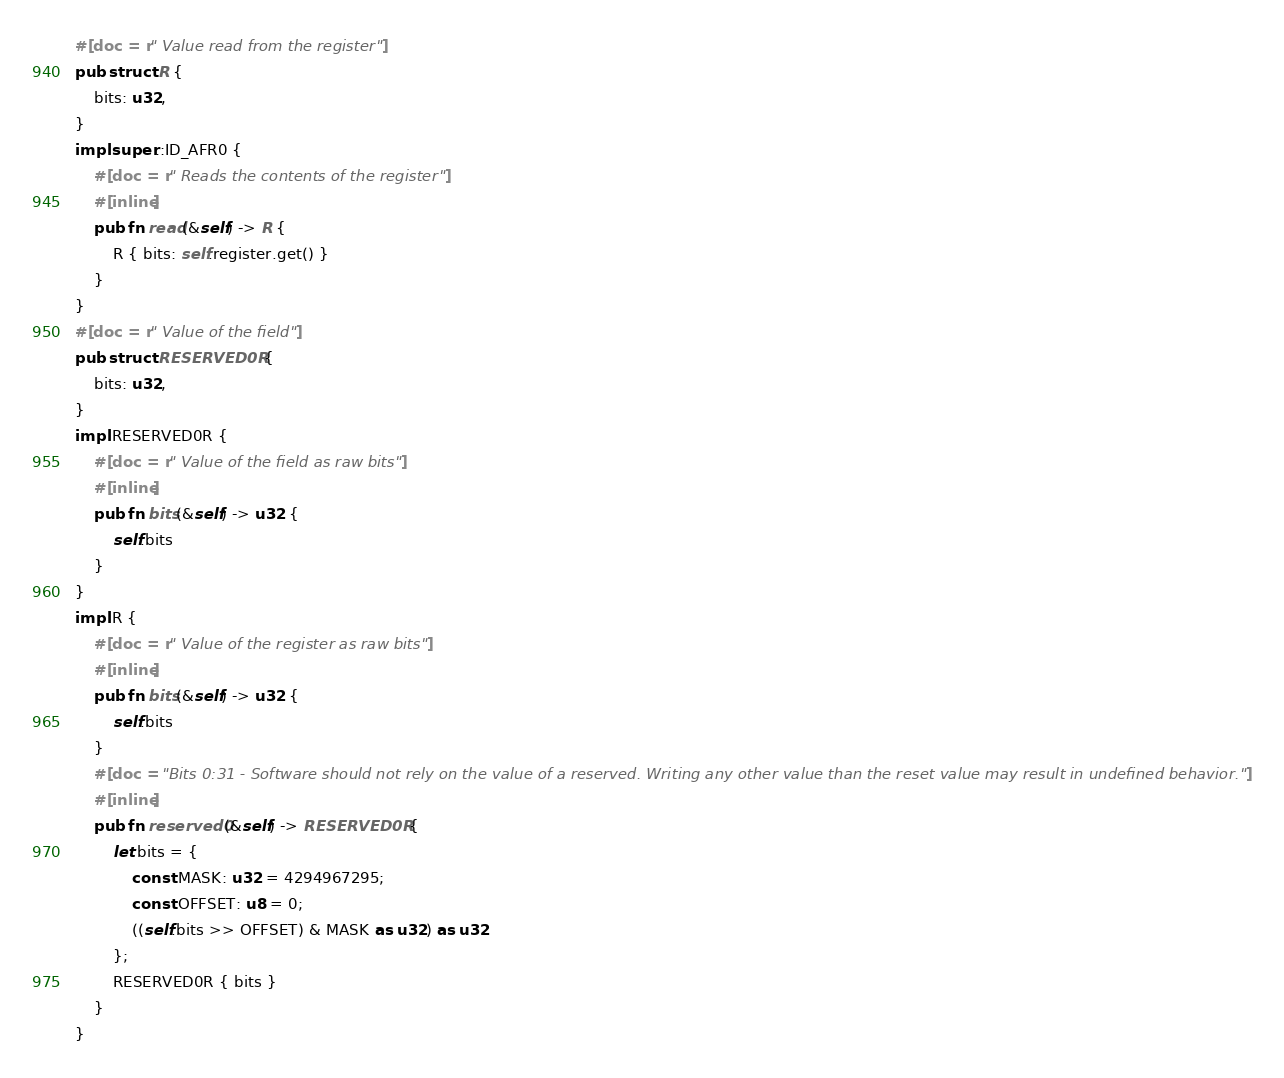Convert code to text. <code><loc_0><loc_0><loc_500><loc_500><_Rust_>#[doc = r" Value read from the register"]
pub struct R {
    bits: u32,
}
impl super::ID_AFR0 {
    #[doc = r" Reads the contents of the register"]
    #[inline]
    pub fn read(&self) -> R {
        R { bits: self.register.get() }
    }
}
#[doc = r" Value of the field"]
pub struct RESERVED0R {
    bits: u32,
}
impl RESERVED0R {
    #[doc = r" Value of the field as raw bits"]
    #[inline]
    pub fn bits(&self) -> u32 {
        self.bits
    }
}
impl R {
    #[doc = r" Value of the register as raw bits"]
    #[inline]
    pub fn bits(&self) -> u32 {
        self.bits
    }
    #[doc = "Bits 0:31 - Software should not rely on the value of a reserved. Writing any other value than the reset value may result in undefined behavior."]
    #[inline]
    pub fn reserved0(&self) -> RESERVED0R {
        let bits = {
            const MASK: u32 = 4294967295;
            const OFFSET: u8 = 0;
            ((self.bits >> OFFSET) & MASK as u32) as u32
        };
        RESERVED0R { bits }
    }
}
</code> 